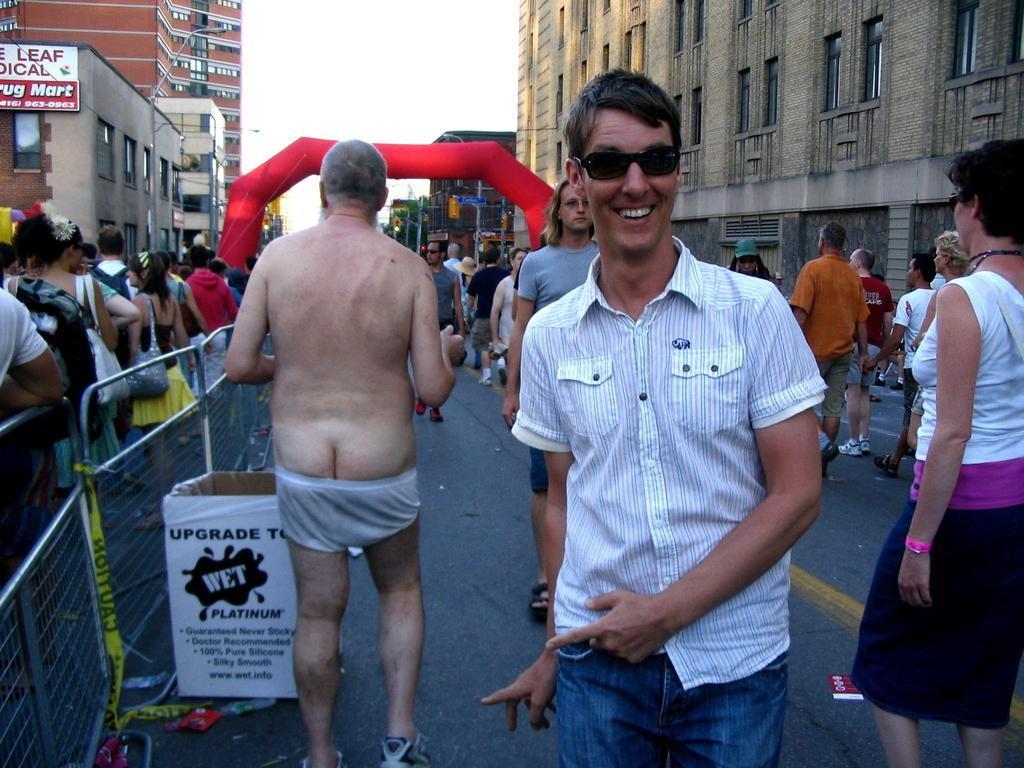What is happening on the road in the image? There are people on the road in the image. What type of barrier is present in the image? There is metal fencing in the image. What can be seen in the background of the image? There are many buildings visible in the image. What are the boards used for in the image? The purpose of the boards in the image is not specified, but they are present. What is visible at the top of the image? The sky is visible at the top of the image. What type of stew is being served in the image? There is no stew present in the image; it features people on the road, metal fencing, buildings, boards, and the sky. What color is the patch on the person's clothing in the image? There is no patch visible on anyone's clothing in the image. 